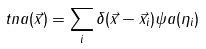<formula> <loc_0><loc_0><loc_500><loc_500>\ t n a ( \vec { x } ) = \sum _ { i } \delta ( \vec { x } - \vec { x } _ { i } ) \psi a ( \eta _ { i } )</formula> 